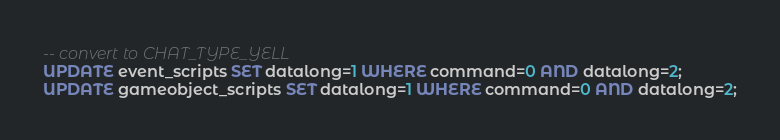<code> <loc_0><loc_0><loc_500><loc_500><_SQL_>
-- convert to CHAT_TYPE_YELL
UPDATE event_scripts SET datalong=1 WHERE command=0 AND datalong=2;
UPDATE gameobject_scripts SET datalong=1 WHERE command=0 AND datalong=2;</code> 